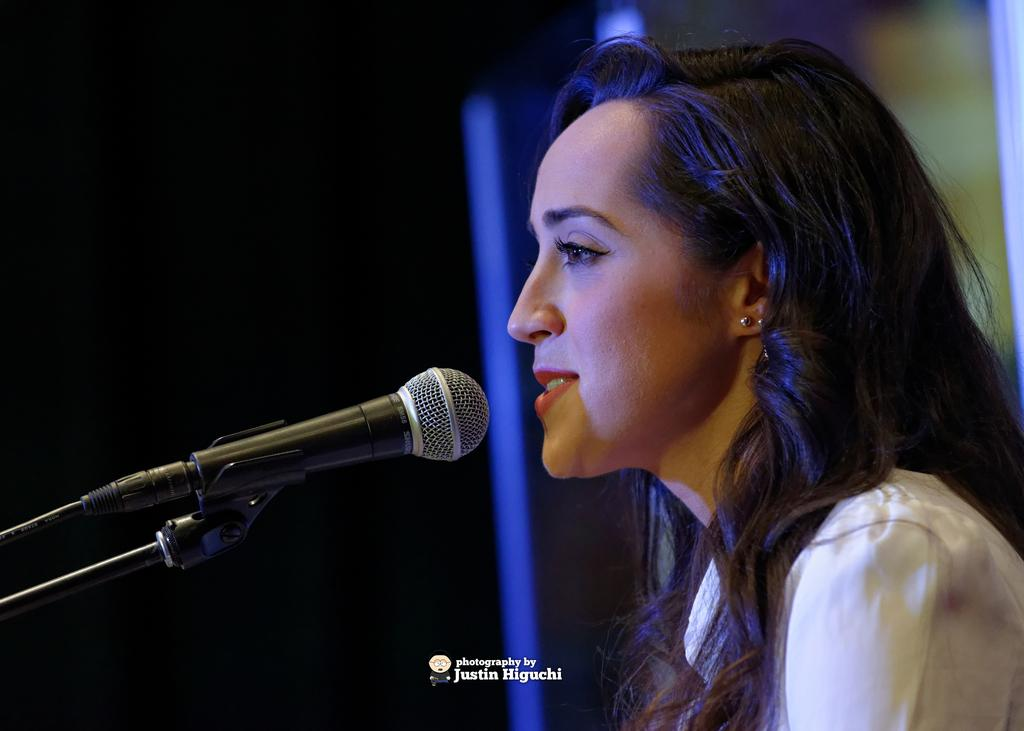Who is the main subject in the image? There is a woman in the image. What object is in front of the woman? There is a microphone in front of the woman. What can be observed about the background of the image? The background of the image is dark. What additional information is provided at the bottom of the image? There is text visible at the bottom of the image. How many giants are visible in the image? There are no giants present in the image. What type of pig can be seen interacting with the woman in the image? There is no pig present in the image; only the woman and the microphone are visible. 